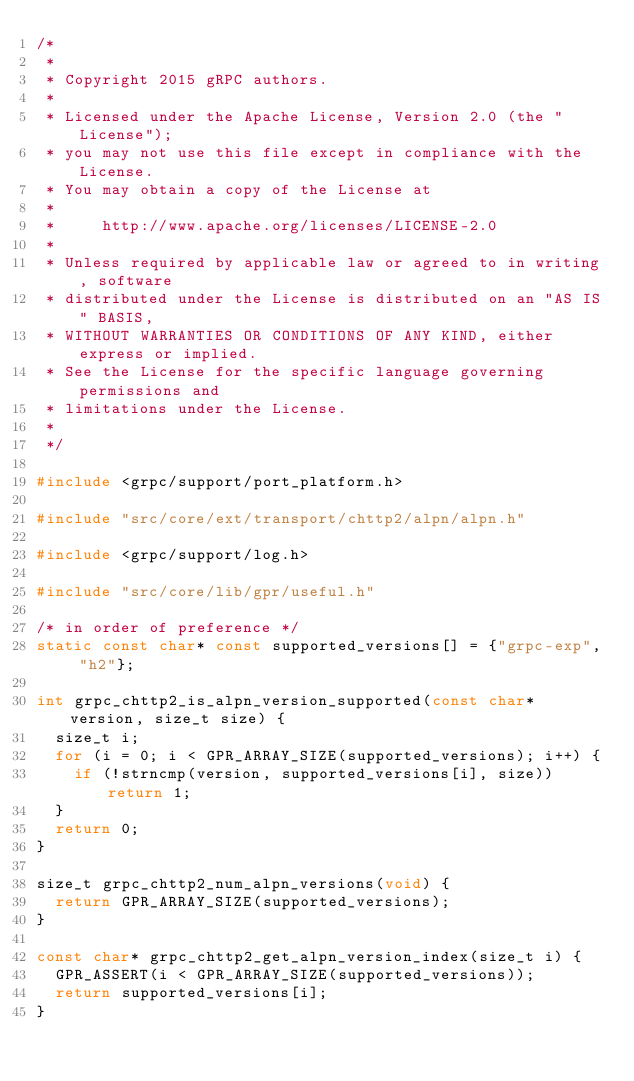<code> <loc_0><loc_0><loc_500><loc_500><_C++_>/*
 *
 * Copyright 2015 gRPC authors.
 *
 * Licensed under the Apache License, Version 2.0 (the "License");
 * you may not use this file except in compliance with the License.
 * You may obtain a copy of the License at
 *
 *     http://www.apache.org/licenses/LICENSE-2.0
 *
 * Unless required by applicable law or agreed to in writing, software
 * distributed under the License is distributed on an "AS IS" BASIS,
 * WITHOUT WARRANTIES OR CONDITIONS OF ANY KIND, either express or implied.
 * See the License for the specific language governing permissions and
 * limitations under the License.
 *
 */

#include <grpc/support/port_platform.h>

#include "src/core/ext/transport/chttp2/alpn/alpn.h"

#include <grpc/support/log.h>

#include "src/core/lib/gpr/useful.h"

/* in order of preference */
static const char* const supported_versions[] = {"grpc-exp", "h2"};

int grpc_chttp2_is_alpn_version_supported(const char* version, size_t size) {
  size_t i;
  for (i = 0; i < GPR_ARRAY_SIZE(supported_versions); i++) {
    if (!strncmp(version, supported_versions[i], size)) return 1;
  }
  return 0;
}

size_t grpc_chttp2_num_alpn_versions(void) {
  return GPR_ARRAY_SIZE(supported_versions);
}

const char* grpc_chttp2_get_alpn_version_index(size_t i) {
  GPR_ASSERT(i < GPR_ARRAY_SIZE(supported_versions));
  return supported_versions[i];
}
</code> 